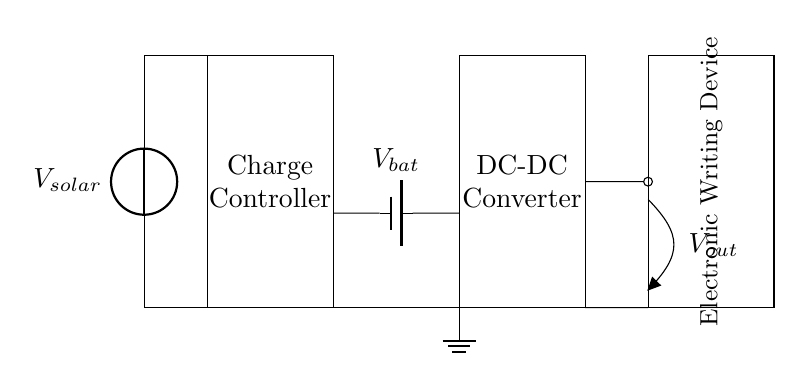What is the source of power for this circuit? The power source is identified as the solar panel, as indicated by the voltage source labeled V_solar.
Answer: solar panel What type of device is being powered by this circuit? The circuit powers an electronic writing device, as shown in the circuit diagram where it is specifically labeled.
Answer: electronic writing device How many main components are visible in this circuit? The components seen are the solar panel, charge controller, battery, DC-DC converter, and the electronic writing device. Counting these gives a total of five.
Answer: five What is the function of the charge controller in this circuit? The charge controller is responsible for managing the power coming from the solar panel and directing it to the battery to prevent overcharging.
Answer: managing power What is the battery's voltage labeled as in the diagram? The battery voltage is indicated as V_bat, which is the point where the battery connects to the circuit.
Answer: V_bat If the solar panel supplies power to multiple devices, what component would help manage this distribution? The charge controller is the component responsible for managing and distributing the power from the solar panel to various devices.
Answer: charge controller 